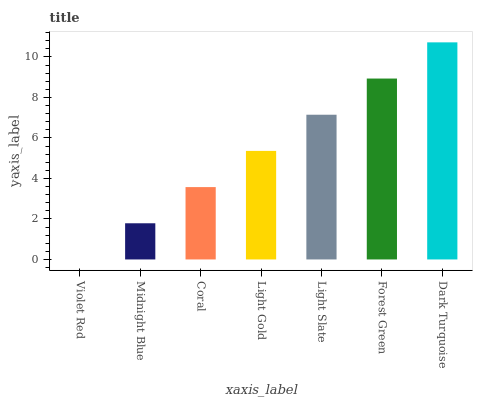Is Midnight Blue the minimum?
Answer yes or no. No. Is Midnight Blue the maximum?
Answer yes or no. No. Is Midnight Blue greater than Violet Red?
Answer yes or no. Yes. Is Violet Red less than Midnight Blue?
Answer yes or no. Yes. Is Violet Red greater than Midnight Blue?
Answer yes or no. No. Is Midnight Blue less than Violet Red?
Answer yes or no. No. Is Light Gold the high median?
Answer yes or no. Yes. Is Light Gold the low median?
Answer yes or no. Yes. Is Light Slate the high median?
Answer yes or no. No. Is Violet Red the low median?
Answer yes or no. No. 